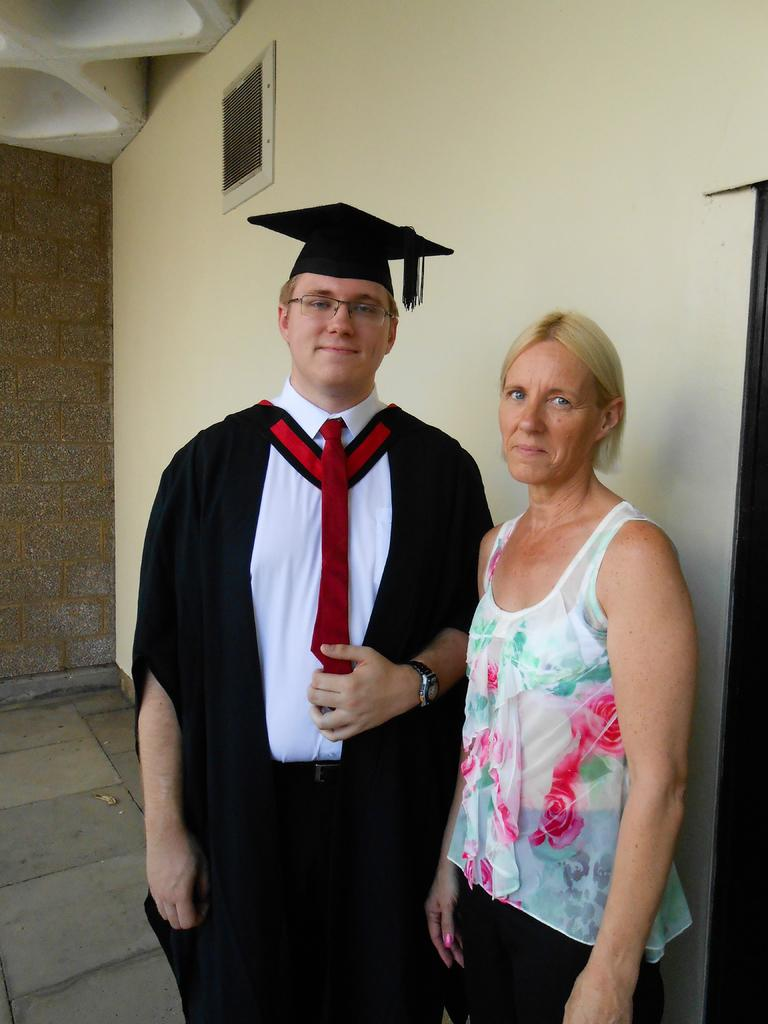How many people are present in the image? There are two people in the image. What can be observed about the clothing of the people in the image? The people are wearing different color dresses. Can you describe any accessories worn by the people in the image? One person is wearing a cap. What is the color of the wall in the background of the image? There is a cream color wall in the background of the image. What type of crayon is being used by the person in the image? There is no crayon present in the image. What is the nature of the exchange between the two people in the image? The image does not depict any exchange between the two people; they are simply standing together. 